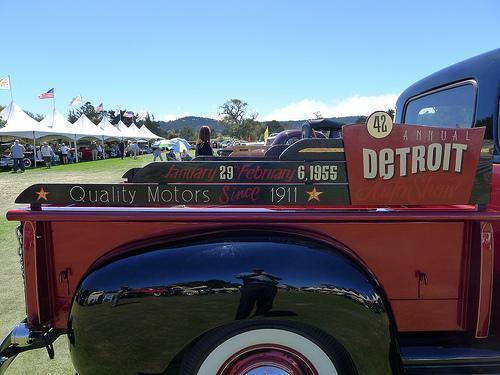How many wheels are there?
Give a very brief answer. 1. 